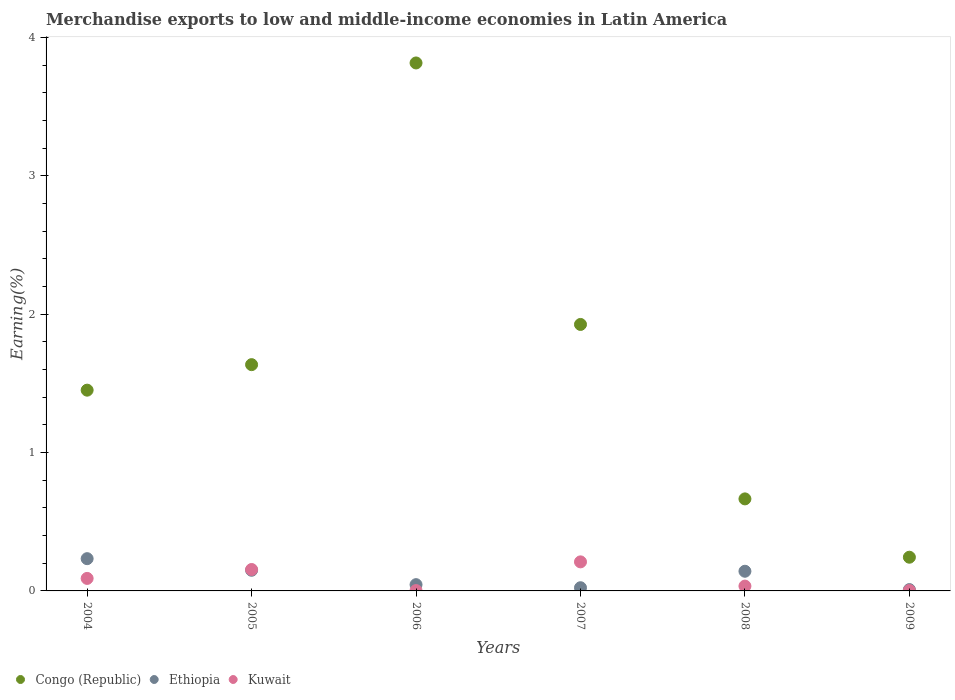What is the percentage of amount earned from merchandise exports in Kuwait in 2006?
Your answer should be compact. 0. Across all years, what is the maximum percentage of amount earned from merchandise exports in Kuwait?
Your answer should be compact. 0.21. Across all years, what is the minimum percentage of amount earned from merchandise exports in Ethiopia?
Ensure brevity in your answer.  0.01. In which year was the percentage of amount earned from merchandise exports in Kuwait maximum?
Your answer should be compact. 2007. What is the total percentage of amount earned from merchandise exports in Congo (Republic) in the graph?
Offer a terse response. 9.74. What is the difference between the percentage of amount earned from merchandise exports in Congo (Republic) in 2004 and that in 2005?
Offer a terse response. -0.18. What is the difference between the percentage of amount earned from merchandise exports in Congo (Republic) in 2006 and the percentage of amount earned from merchandise exports in Kuwait in 2007?
Your response must be concise. 3.61. What is the average percentage of amount earned from merchandise exports in Ethiopia per year?
Your response must be concise. 0.1. In the year 2006, what is the difference between the percentage of amount earned from merchandise exports in Ethiopia and percentage of amount earned from merchandise exports in Kuwait?
Your answer should be very brief. 0.04. What is the ratio of the percentage of amount earned from merchandise exports in Kuwait in 2004 to that in 2006?
Make the answer very short. 34.98. Is the percentage of amount earned from merchandise exports in Kuwait in 2004 less than that in 2008?
Provide a short and direct response. No. What is the difference between the highest and the second highest percentage of amount earned from merchandise exports in Congo (Republic)?
Provide a succinct answer. 1.89. What is the difference between the highest and the lowest percentage of amount earned from merchandise exports in Congo (Republic)?
Provide a short and direct response. 3.57. In how many years, is the percentage of amount earned from merchandise exports in Kuwait greater than the average percentage of amount earned from merchandise exports in Kuwait taken over all years?
Make the answer very short. 3. Is the sum of the percentage of amount earned from merchandise exports in Ethiopia in 2005 and 2008 greater than the maximum percentage of amount earned from merchandise exports in Kuwait across all years?
Provide a short and direct response. Yes. Is it the case that in every year, the sum of the percentage of amount earned from merchandise exports in Kuwait and percentage of amount earned from merchandise exports in Congo (Republic)  is greater than the percentage of amount earned from merchandise exports in Ethiopia?
Give a very brief answer. Yes. Does the percentage of amount earned from merchandise exports in Ethiopia monotonically increase over the years?
Offer a very short reply. No. Is the percentage of amount earned from merchandise exports in Ethiopia strictly greater than the percentage of amount earned from merchandise exports in Kuwait over the years?
Give a very brief answer. No. What is the difference between two consecutive major ticks on the Y-axis?
Give a very brief answer. 1. Does the graph contain any zero values?
Give a very brief answer. No. Where does the legend appear in the graph?
Your response must be concise. Bottom left. How many legend labels are there?
Your answer should be very brief. 3. What is the title of the graph?
Provide a succinct answer. Merchandise exports to low and middle-income economies in Latin America. What is the label or title of the Y-axis?
Keep it short and to the point. Earning(%). What is the Earning(%) of Congo (Republic) in 2004?
Give a very brief answer. 1.45. What is the Earning(%) in Ethiopia in 2004?
Your answer should be very brief. 0.23. What is the Earning(%) in Kuwait in 2004?
Offer a terse response. 0.09. What is the Earning(%) in Congo (Republic) in 2005?
Give a very brief answer. 1.64. What is the Earning(%) of Ethiopia in 2005?
Give a very brief answer. 0.15. What is the Earning(%) of Kuwait in 2005?
Your answer should be compact. 0.15. What is the Earning(%) of Congo (Republic) in 2006?
Make the answer very short. 3.82. What is the Earning(%) in Ethiopia in 2006?
Provide a succinct answer. 0.05. What is the Earning(%) in Kuwait in 2006?
Provide a short and direct response. 0. What is the Earning(%) of Congo (Republic) in 2007?
Provide a short and direct response. 1.93. What is the Earning(%) of Ethiopia in 2007?
Ensure brevity in your answer.  0.02. What is the Earning(%) of Kuwait in 2007?
Keep it short and to the point. 0.21. What is the Earning(%) in Congo (Republic) in 2008?
Your answer should be very brief. 0.67. What is the Earning(%) of Ethiopia in 2008?
Provide a short and direct response. 0.14. What is the Earning(%) in Kuwait in 2008?
Give a very brief answer. 0.03. What is the Earning(%) in Congo (Republic) in 2009?
Provide a succinct answer. 0.24. What is the Earning(%) in Ethiopia in 2009?
Offer a very short reply. 0.01. What is the Earning(%) of Kuwait in 2009?
Offer a terse response. 0. Across all years, what is the maximum Earning(%) in Congo (Republic)?
Offer a terse response. 3.82. Across all years, what is the maximum Earning(%) of Ethiopia?
Give a very brief answer. 0.23. Across all years, what is the maximum Earning(%) in Kuwait?
Give a very brief answer. 0.21. Across all years, what is the minimum Earning(%) of Congo (Republic)?
Provide a short and direct response. 0.24. Across all years, what is the minimum Earning(%) in Ethiopia?
Provide a succinct answer. 0.01. Across all years, what is the minimum Earning(%) in Kuwait?
Give a very brief answer. 0. What is the total Earning(%) in Congo (Republic) in the graph?
Offer a very short reply. 9.74. What is the total Earning(%) in Ethiopia in the graph?
Ensure brevity in your answer.  0.6. What is the total Earning(%) in Kuwait in the graph?
Offer a very short reply. 0.5. What is the difference between the Earning(%) of Congo (Republic) in 2004 and that in 2005?
Offer a very short reply. -0.18. What is the difference between the Earning(%) of Ethiopia in 2004 and that in 2005?
Your answer should be very brief. 0.08. What is the difference between the Earning(%) of Kuwait in 2004 and that in 2005?
Provide a short and direct response. -0.06. What is the difference between the Earning(%) of Congo (Republic) in 2004 and that in 2006?
Give a very brief answer. -2.37. What is the difference between the Earning(%) in Ethiopia in 2004 and that in 2006?
Offer a very short reply. 0.19. What is the difference between the Earning(%) of Kuwait in 2004 and that in 2006?
Provide a short and direct response. 0.09. What is the difference between the Earning(%) of Congo (Republic) in 2004 and that in 2007?
Offer a very short reply. -0.47. What is the difference between the Earning(%) of Ethiopia in 2004 and that in 2007?
Offer a very short reply. 0.21. What is the difference between the Earning(%) of Kuwait in 2004 and that in 2007?
Give a very brief answer. -0.12. What is the difference between the Earning(%) in Congo (Republic) in 2004 and that in 2008?
Provide a succinct answer. 0.79. What is the difference between the Earning(%) in Ethiopia in 2004 and that in 2008?
Provide a short and direct response. 0.09. What is the difference between the Earning(%) in Kuwait in 2004 and that in 2008?
Give a very brief answer. 0.06. What is the difference between the Earning(%) of Congo (Republic) in 2004 and that in 2009?
Offer a terse response. 1.21. What is the difference between the Earning(%) in Ethiopia in 2004 and that in 2009?
Give a very brief answer. 0.22. What is the difference between the Earning(%) of Kuwait in 2004 and that in 2009?
Ensure brevity in your answer.  0.09. What is the difference between the Earning(%) of Congo (Republic) in 2005 and that in 2006?
Offer a very short reply. -2.18. What is the difference between the Earning(%) in Ethiopia in 2005 and that in 2006?
Your answer should be compact. 0.1. What is the difference between the Earning(%) of Kuwait in 2005 and that in 2006?
Keep it short and to the point. 0.15. What is the difference between the Earning(%) in Congo (Republic) in 2005 and that in 2007?
Provide a succinct answer. -0.29. What is the difference between the Earning(%) in Ethiopia in 2005 and that in 2007?
Offer a very short reply. 0.13. What is the difference between the Earning(%) in Kuwait in 2005 and that in 2007?
Give a very brief answer. -0.06. What is the difference between the Earning(%) of Congo (Republic) in 2005 and that in 2008?
Ensure brevity in your answer.  0.97. What is the difference between the Earning(%) in Ethiopia in 2005 and that in 2008?
Offer a terse response. 0.01. What is the difference between the Earning(%) in Kuwait in 2005 and that in 2008?
Keep it short and to the point. 0.12. What is the difference between the Earning(%) of Congo (Republic) in 2005 and that in 2009?
Your response must be concise. 1.39. What is the difference between the Earning(%) in Ethiopia in 2005 and that in 2009?
Your response must be concise. 0.14. What is the difference between the Earning(%) of Kuwait in 2005 and that in 2009?
Offer a very short reply. 0.15. What is the difference between the Earning(%) in Congo (Republic) in 2006 and that in 2007?
Give a very brief answer. 1.89. What is the difference between the Earning(%) in Ethiopia in 2006 and that in 2007?
Give a very brief answer. 0.02. What is the difference between the Earning(%) of Kuwait in 2006 and that in 2007?
Offer a very short reply. -0.21. What is the difference between the Earning(%) of Congo (Republic) in 2006 and that in 2008?
Offer a terse response. 3.15. What is the difference between the Earning(%) in Ethiopia in 2006 and that in 2008?
Provide a succinct answer. -0.1. What is the difference between the Earning(%) of Kuwait in 2006 and that in 2008?
Offer a terse response. -0.03. What is the difference between the Earning(%) of Congo (Republic) in 2006 and that in 2009?
Offer a terse response. 3.57. What is the difference between the Earning(%) in Ethiopia in 2006 and that in 2009?
Make the answer very short. 0.04. What is the difference between the Earning(%) in Kuwait in 2006 and that in 2009?
Provide a succinct answer. -0. What is the difference between the Earning(%) in Congo (Republic) in 2007 and that in 2008?
Ensure brevity in your answer.  1.26. What is the difference between the Earning(%) of Ethiopia in 2007 and that in 2008?
Ensure brevity in your answer.  -0.12. What is the difference between the Earning(%) of Kuwait in 2007 and that in 2008?
Offer a terse response. 0.18. What is the difference between the Earning(%) of Congo (Republic) in 2007 and that in 2009?
Your response must be concise. 1.68. What is the difference between the Earning(%) in Ethiopia in 2007 and that in 2009?
Provide a succinct answer. 0.01. What is the difference between the Earning(%) of Kuwait in 2007 and that in 2009?
Offer a terse response. 0.21. What is the difference between the Earning(%) of Congo (Republic) in 2008 and that in 2009?
Your response must be concise. 0.42. What is the difference between the Earning(%) in Ethiopia in 2008 and that in 2009?
Ensure brevity in your answer.  0.13. What is the difference between the Earning(%) in Kuwait in 2008 and that in 2009?
Keep it short and to the point. 0.03. What is the difference between the Earning(%) in Congo (Republic) in 2004 and the Earning(%) in Ethiopia in 2005?
Provide a succinct answer. 1.3. What is the difference between the Earning(%) in Congo (Republic) in 2004 and the Earning(%) in Kuwait in 2005?
Provide a succinct answer. 1.3. What is the difference between the Earning(%) in Ethiopia in 2004 and the Earning(%) in Kuwait in 2005?
Provide a succinct answer. 0.08. What is the difference between the Earning(%) in Congo (Republic) in 2004 and the Earning(%) in Ethiopia in 2006?
Make the answer very short. 1.41. What is the difference between the Earning(%) in Congo (Republic) in 2004 and the Earning(%) in Kuwait in 2006?
Offer a terse response. 1.45. What is the difference between the Earning(%) of Ethiopia in 2004 and the Earning(%) of Kuwait in 2006?
Keep it short and to the point. 0.23. What is the difference between the Earning(%) in Congo (Republic) in 2004 and the Earning(%) in Ethiopia in 2007?
Offer a very short reply. 1.43. What is the difference between the Earning(%) in Congo (Republic) in 2004 and the Earning(%) in Kuwait in 2007?
Your answer should be compact. 1.24. What is the difference between the Earning(%) in Ethiopia in 2004 and the Earning(%) in Kuwait in 2007?
Keep it short and to the point. 0.02. What is the difference between the Earning(%) in Congo (Republic) in 2004 and the Earning(%) in Ethiopia in 2008?
Keep it short and to the point. 1.31. What is the difference between the Earning(%) in Congo (Republic) in 2004 and the Earning(%) in Kuwait in 2008?
Offer a very short reply. 1.42. What is the difference between the Earning(%) of Ethiopia in 2004 and the Earning(%) of Kuwait in 2008?
Your answer should be compact. 0.2. What is the difference between the Earning(%) of Congo (Republic) in 2004 and the Earning(%) of Ethiopia in 2009?
Your response must be concise. 1.44. What is the difference between the Earning(%) of Congo (Republic) in 2004 and the Earning(%) of Kuwait in 2009?
Offer a terse response. 1.45. What is the difference between the Earning(%) in Ethiopia in 2004 and the Earning(%) in Kuwait in 2009?
Your answer should be compact. 0.23. What is the difference between the Earning(%) of Congo (Republic) in 2005 and the Earning(%) of Ethiopia in 2006?
Make the answer very short. 1.59. What is the difference between the Earning(%) of Congo (Republic) in 2005 and the Earning(%) of Kuwait in 2006?
Keep it short and to the point. 1.63. What is the difference between the Earning(%) in Ethiopia in 2005 and the Earning(%) in Kuwait in 2006?
Offer a very short reply. 0.15. What is the difference between the Earning(%) in Congo (Republic) in 2005 and the Earning(%) in Ethiopia in 2007?
Your answer should be very brief. 1.61. What is the difference between the Earning(%) of Congo (Republic) in 2005 and the Earning(%) of Kuwait in 2007?
Offer a very short reply. 1.43. What is the difference between the Earning(%) of Ethiopia in 2005 and the Earning(%) of Kuwait in 2007?
Give a very brief answer. -0.06. What is the difference between the Earning(%) of Congo (Republic) in 2005 and the Earning(%) of Ethiopia in 2008?
Keep it short and to the point. 1.49. What is the difference between the Earning(%) in Congo (Republic) in 2005 and the Earning(%) in Kuwait in 2008?
Offer a very short reply. 1.6. What is the difference between the Earning(%) in Ethiopia in 2005 and the Earning(%) in Kuwait in 2008?
Keep it short and to the point. 0.11. What is the difference between the Earning(%) in Congo (Republic) in 2005 and the Earning(%) in Ethiopia in 2009?
Your answer should be very brief. 1.63. What is the difference between the Earning(%) in Congo (Republic) in 2005 and the Earning(%) in Kuwait in 2009?
Ensure brevity in your answer.  1.63. What is the difference between the Earning(%) of Ethiopia in 2005 and the Earning(%) of Kuwait in 2009?
Offer a terse response. 0.15. What is the difference between the Earning(%) in Congo (Republic) in 2006 and the Earning(%) in Ethiopia in 2007?
Your answer should be very brief. 3.79. What is the difference between the Earning(%) of Congo (Republic) in 2006 and the Earning(%) of Kuwait in 2007?
Offer a very short reply. 3.61. What is the difference between the Earning(%) in Ethiopia in 2006 and the Earning(%) in Kuwait in 2007?
Provide a succinct answer. -0.16. What is the difference between the Earning(%) in Congo (Republic) in 2006 and the Earning(%) in Ethiopia in 2008?
Your answer should be compact. 3.67. What is the difference between the Earning(%) of Congo (Republic) in 2006 and the Earning(%) of Kuwait in 2008?
Offer a very short reply. 3.78. What is the difference between the Earning(%) in Ethiopia in 2006 and the Earning(%) in Kuwait in 2008?
Your answer should be compact. 0.01. What is the difference between the Earning(%) of Congo (Republic) in 2006 and the Earning(%) of Ethiopia in 2009?
Your response must be concise. 3.81. What is the difference between the Earning(%) in Congo (Republic) in 2006 and the Earning(%) in Kuwait in 2009?
Give a very brief answer. 3.81. What is the difference between the Earning(%) in Ethiopia in 2006 and the Earning(%) in Kuwait in 2009?
Ensure brevity in your answer.  0.04. What is the difference between the Earning(%) of Congo (Republic) in 2007 and the Earning(%) of Ethiopia in 2008?
Provide a succinct answer. 1.78. What is the difference between the Earning(%) in Congo (Republic) in 2007 and the Earning(%) in Kuwait in 2008?
Provide a short and direct response. 1.89. What is the difference between the Earning(%) of Ethiopia in 2007 and the Earning(%) of Kuwait in 2008?
Provide a succinct answer. -0.01. What is the difference between the Earning(%) of Congo (Republic) in 2007 and the Earning(%) of Ethiopia in 2009?
Ensure brevity in your answer.  1.92. What is the difference between the Earning(%) of Congo (Republic) in 2007 and the Earning(%) of Kuwait in 2009?
Your answer should be compact. 1.92. What is the difference between the Earning(%) of Ethiopia in 2007 and the Earning(%) of Kuwait in 2009?
Offer a terse response. 0.02. What is the difference between the Earning(%) in Congo (Republic) in 2008 and the Earning(%) in Ethiopia in 2009?
Ensure brevity in your answer.  0.66. What is the difference between the Earning(%) in Congo (Republic) in 2008 and the Earning(%) in Kuwait in 2009?
Give a very brief answer. 0.66. What is the difference between the Earning(%) of Ethiopia in 2008 and the Earning(%) of Kuwait in 2009?
Your answer should be very brief. 0.14. What is the average Earning(%) in Congo (Republic) per year?
Offer a terse response. 1.62. What is the average Earning(%) of Ethiopia per year?
Provide a succinct answer. 0.1. What is the average Earning(%) in Kuwait per year?
Provide a short and direct response. 0.08. In the year 2004, what is the difference between the Earning(%) in Congo (Republic) and Earning(%) in Ethiopia?
Give a very brief answer. 1.22. In the year 2004, what is the difference between the Earning(%) in Congo (Republic) and Earning(%) in Kuwait?
Your answer should be very brief. 1.36. In the year 2004, what is the difference between the Earning(%) in Ethiopia and Earning(%) in Kuwait?
Offer a terse response. 0.14. In the year 2005, what is the difference between the Earning(%) of Congo (Republic) and Earning(%) of Ethiopia?
Give a very brief answer. 1.49. In the year 2005, what is the difference between the Earning(%) in Congo (Republic) and Earning(%) in Kuwait?
Offer a terse response. 1.48. In the year 2005, what is the difference between the Earning(%) in Ethiopia and Earning(%) in Kuwait?
Keep it short and to the point. -0.01. In the year 2006, what is the difference between the Earning(%) of Congo (Republic) and Earning(%) of Ethiopia?
Make the answer very short. 3.77. In the year 2006, what is the difference between the Earning(%) of Congo (Republic) and Earning(%) of Kuwait?
Offer a very short reply. 3.81. In the year 2006, what is the difference between the Earning(%) of Ethiopia and Earning(%) of Kuwait?
Make the answer very short. 0.04. In the year 2007, what is the difference between the Earning(%) in Congo (Republic) and Earning(%) in Ethiopia?
Your response must be concise. 1.9. In the year 2007, what is the difference between the Earning(%) of Congo (Republic) and Earning(%) of Kuwait?
Ensure brevity in your answer.  1.72. In the year 2007, what is the difference between the Earning(%) in Ethiopia and Earning(%) in Kuwait?
Offer a very short reply. -0.19. In the year 2008, what is the difference between the Earning(%) of Congo (Republic) and Earning(%) of Ethiopia?
Your answer should be compact. 0.52. In the year 2008, what is the difference between the Earning(%) in Congo (Republic) and Earning(%) in Kuwait?
Give a very brief answer. 0.63. In the year 2008, what is the difference between the Earning(%) of Ethiopia and Earning(%) of Kuwait?
Provide a succinct answer. 0.11. In the year 2009, what is the difference between the Earning(%) of Congo (Republic) and Earning(%) of Ethiopia?
Your answer should be compact. 0.23. In the year 2009, what is the difference between the Earning(%) of Congo (Republic) and Earning(%) of Kuwait?
Provide a short and direct response. 0.24. In the year 2009, what is the difference between the Earning(%) in Ethiopia and Earning(%) in Kuwait?
Offer a terse response. 0.01. What is the ratio of the Earning(%) of Congo (Republic) in 2004 to that in 2005?
Offer a terse response. 0.89. What is the ratio of the Earning(%) of Ethiopia in 2004 to that in 2005?
Make the answer very short. 1.56. What is the ratio of the Earning(%) in Kuwait in 2004 to that in 2005?
Ensure brevity in your answer.  0.58. What is the ratio of the Earning(%) of Congo (Republic) in 2004 to that in 2006?
Make the answer very short. 0.38. What is the ratio of the Earning(%) of Ethiopia in 2004 to that in 2006?
Provide a short and direct response. 5.15. What is the ratio of the Earning(%) in Kuwait in 2004 to that in 2006?
Give a very brief answer. 34.98. What is the ratio of the Earning(%) in Congo (Republic) in 2004 to that in 2007?
Your answer should be very brief. 0.75. What is the ratio of the Earning(%) of Ethiopia in 2004 to that in 2007?
Provide a short and direct response. 10.08. What is the ratio of the Earning(%) in Kuwait in 2004 to that in 2007?
Provide a short and direct response. 0.43. What is the ratio of the Earning(%) in Congo (Republic) in 2004 to that in 2008?
Provide a short and direct response. 2.18. What is the ratio of the Earning(%) of Ethiopia in 2004 to that in 2008?
Offer a very short reply. 1.64. What is the ratio of the Earning(%) of Kuwait in 2004 to that in 2008?
Your answer should be very brief. 2.6. What is the ratio of the Earning(%) of Congo (Republic) in 2004 to that in 2009?
Your answer should be compact. 5.96. What is the ratio of the Earning(%) in Ethiopia in 2004 to that in 2009?
Keep it short and to the point. 24.49. What is the ratio of the Earning(%) of Kuwait in 2004 to that in 2009?
Your answer should be compact. 29.73. What is the ratio of the Earning(%) in Congo (Republic) in 2005 to that in 2006?
Provide a short and direct response. 0.43. What is the ratio of the Earning(%) of Ethiopia in 2005 to that in 2006?
Your answer should be very brief. 3.3. What is the ratio of the Earning(%) of Kuwait in 2005 to that in 2006?
Offer a very short reply. 59.91. What is the ratio of the Earning(%) of Congo (Republic) in 2005 to that in 2007?
Keep it short and to the point. 0.85. What is the ratio of the Earning(%) in Ethiopia in 2005 to that in 2007?
Make the answer very short. 6.45. What is the ratio of the Earning(%) of Kuwait in 2005 to that in 2007?
Make the answer very short. 0.74. What is the ratio of the Earning(%) in Congo (Republic) in 2005 to that in 2008?
Offer a very short reply. 2.46. What is the ratio of the Earning(%) in Ethiopia in 2005 to that in 2008?
Your answer should be compact. 1.05. What is the ratio of the Earning(%) of Kuwait in 2005 to that in 2008?
Offer a very short reply. 4.45. What is the ratio of the Earning(%) in Congo (Republic) in 2005 to that in 2009?
Your answer should be very brief. 6.71. What is the ratio of the Earning(%) of Ethiopia in 2005 to that in 2009?
Your response must be concise. 15.68. What is the ratio of the Earning(%) in Kuwait in 2005 to that in 2009?
Give a very brief answer. 50.91. What is the ratio of the Earning(%) in Congo (Republic) in 2006 to that in 2007?
Make the answer very short. 1.98. What is the ratio of the Earning(%) of Ethiopia in 2006 to that in 2007?
Provide a short and direct response. 1.96. What is the ratio of the Earning(%) in Kuwait in 2006 to that in 2007?
Your response must be concise. 0.01. What is the ratio of the Earning(%) in Congo (Republic) in 2006 to that in 2008?
Give a very brief answer. 5.74. What is the ratio of the Earning(%) of Ethiopia in 2006 to that in 2008?
Ensure brevity in your answer.  0.32. What is the ratio of the Earning(%) of Kuwait in 2006 to that in 2008?
Ensure brevity in your answer.  0.07. What is the ratio of the Earning(%) of Congo (Republic) in 2006 to that in 2009?
Your answer should be compact. 15.67. What is the ratio of the Earning(%) of Ethiopia in 2006 to that in 2009?
Your response must be concise. 4.76. What is the ratio of the Earning(%) of Kuwait in 2006 to that in 2009?
Keep it short and to the point. 0.85. What is the ratio of the Earning(%) of Congo (Republic) in 2007 to that in 2008?
Keep it short and to the point. 2.9. What is the ratio of the Earning(%) in Ethiopia in 2007 to that in 2008?
Ensure brevity in your answer.  0.16. What is the ratio of the Earning(%) of Kuwait in 2007 to that in 2008?
Your response must be concise. 6.03. What is the ratio of the Earning(%) in Congo (Republic) in 2007 to that in 2009?
Provide a short and direct response. 7.91. What is the ratio of the Earning(%) in Ethiopia in 2007 to that in 2009?
Provide a short and direct response. 2.43. What is the ratio of the Earning(%) of Kuwait in 2007 to that in 2009?
Provide a succinct answer. 69.05. What is the ratio of the Earning(%) in Congo (Republic) in 2008 to that in 2009?
Ensure brevity in your answer.  2.73. What is the ratio of the Earning(%) of Ethiopia in 2008 to that in 2009?
Keep it short and to the point. 14.93. What is the ratio of the Earning(%) of Kuwait in 2008 to that in 2009?
Make the answer very short. 11.44. What is the difference between the highest and the second highest Earning(%) in Congo (Republic)?
Offer a terse response. 1.89. What is the difference between the highest and the second highest Earning(%) in Ethiopia?
Provide a succinct answer. 0.08. What is the difference between the highest and the second highest Earning(%) of Kuwait?
Make the answer very short. 0.06. What is the difference between the highest and the lowest Earning(%) of Congo (Republic)?
Make the answer very short. 3.57. What is the difference between the highest and the lowest Earning(%) in Ethiopia?
Keep it short and to the point. 0.22. What is the difference between the highest and the lowest Earning(%) in Kuwait?
Your answer should be compact. 0.21. 